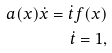<formula> <loc_0><loc_0><loc_500><loc_500>a ( x ) \dot { x } = \dot { t } f ( x ) \\ \dot { t } = 1 ,</formula> 